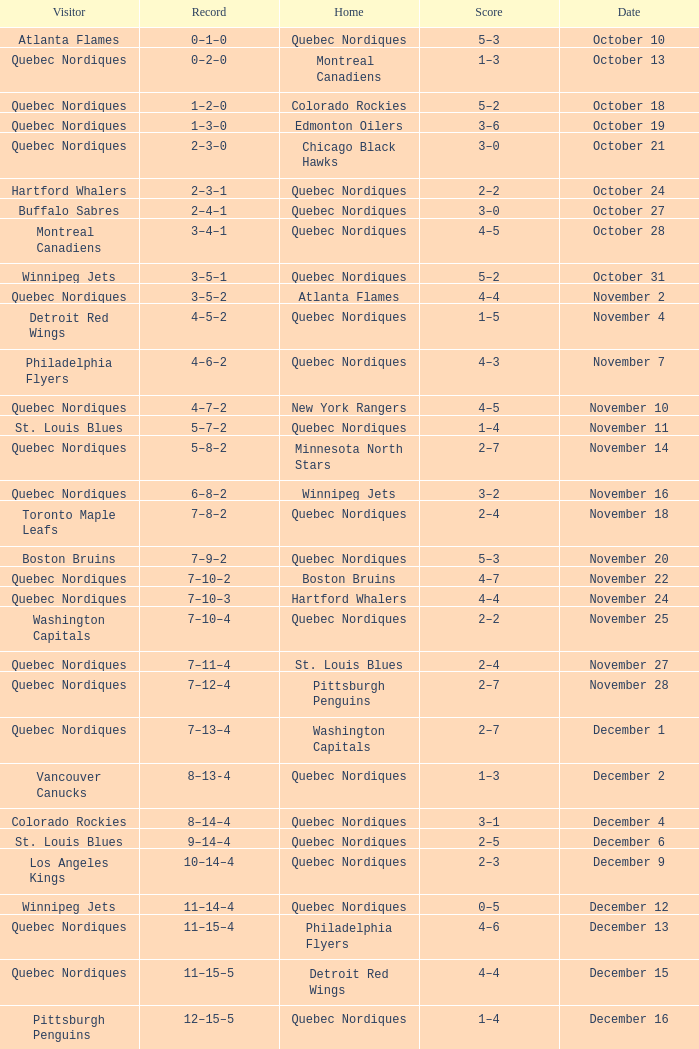Give me the full table as a dictionary. {'header': ['Visitor', 'Record', 'Home', 'Score', 'Date'], 'rows': [['Atlanta Flames', '0–1–0', 'Quebec Nordiques', '5–3', 'October 10'], ['Quebec Nordiques', '0–2–0', 'Montreal Canadiens', '1–3', 'October 13'], ['Quebec Nordiques', '1–2–0', 'Colorado Rockies', '5–2', 'October 18'], ['Quebec Nordiques', '1–3–0', 'Edmonton Oilers', '3–6', 'October 19'], ['Quebec Nordiques', '2–3–0', 'Chicago Black Hawks', '3–0', 'October 21'], ['Hartford Whalers', '2–3–1', 'Quebec Nordiques', '2–2', 'October 24'], ['Buffalo Sabres', '2–4–1', 'Quebec Nordiques', '3–0', 'October 27'], ['Montreal Canadiens', '3–4–1', 'Quebec Nordiques', '4–5', 'October 28'], ['Winnipeg Jets', '3–5–1', 'Quebec Nordiques', '5–2', 'October 31'], ['Quebec Nordiques', '3–5–2', 'Atlanta Flames', '4–4', 'November 2'], ['Detroit Red Wings', '4–5–2', 'Quebec Nordiques', '1–5', 'November 4'], ['Philadelphia Flyers', '4–6–2', 'Quebec Nordiques', '4–3', 'November 7'], ['Quebec Nordiques', '4–7–2', 'New York Rangers', '4–5', 'November 10'], ['St. Louis Blues', '5–7–2', 'Quebec Nordiques', '1–4', 'November 11'], ['Quebec Nordiques', '5–8–2', 'Minnesota North Stars', '2–7', 'November 14'], ['Quebec Nordiques', '6–8–2', 'Winnipeg Jets', '3–2', 'November 16'], ['Toronto Maple Leafs', '7–8–2', 'Quebec Nordiques', '2–4', 'November 18'], ['Boston Bruins', '7–9–2', 'Quebec Nordiques', '5–3', 'November 20'], ['Quebec Nordiques', '7–10–2', 'Boston Bruins', '4–7', 'November 22'], ['Quebec Nordiques', '7–10–3', 'Hartford Whalers', '4–4', 'November 24'], ['Washington Capitals', '7–10–4', 'Quebec Nordiques', '2–2', 'November 25'], ['Quebec Nordiques', '7–11–4', 'St. Louis Blues', '2–4', 'November 27'], ['Quebec Nordiques', '7–12–4', 'Pittsburgh Penguins', '2–7', 'November 28'], ['Quebec Nordiques', '7–13–4', 'Washington Capitals', '2–7', 'December 1'], ['Vancouver Canucks', '8–13-4', 'Quebec Nordiques', '1–3', 'December 2'], ['Colorado Rockies', '8–14–4', 'Quebec Nordiques', '3–1', 'December 4'], ['St. Louis Blues', '9–14–4', 'Quebec Nordiques', '2–5', 'December 6'], ['Los Angeles Kings', '10–14–4', 'Quebec Nordiques', '2–3', 'December 9'], ['Winnipeg Jets', '11–14–4', 'Quebec Nordiques', '0–5', 'December 12'], ['Quebec Nordiques', '11–15–4', 'Philadelphia Flyers', '4–6', 'December 13'], ['Quebec Nordiques', '11–15–5', 'Detroit Red Wings', '4–4', 'December 15'], ['Pittsburgh Penguins', '12–15–5', 'Quebec Nordiques', '1–4', 'December 16'], ['Colorado Rockies', '13–15–5', 'Quebec Nordiques', '3–6', 'December 19'], ['Quebec Nordiques', '14–15–5', 'Buffalo Sabres', '3–1', 'December 23'], ['Quebec Nordiques', '14–16–5', 'Los Angeles Kings', '0–3', 'December 27'], ['Quebec Nordiques', '14–17–5', 'Vancouver Canucks', '2–6', 'December 29'], ['Quebec Nordiques', '15–17–5', 'Edmonton Oilers', '2–1', 'December 30'], ['New York Rangers', '15–17–6', 'Quebec Nordiques', '3–3', 'January 2'], ['Quebec Nordiques', '16–17–6', 'Toronto Maple Leafs', '7–3', 'January 5'], ['Edmonton Oilers', '17–17–6', 'Quebec Nordiques', '2–3', 'January 9'], ['Quebec Nordiques', '17–18–6', 'Atlanta Flames', '3–4', 'January 11'], ['Quebec Nordiques', '17–19–6', 'St. Louis Blues', '2–8', 'January 12'], ['Boston Bruins', '17–20–6', 'Quebec Nordiques', '3–1', 'January 16'], ['Quebec Nordiques', '17–21–6', 'New York Islanders', '1–3', 'January 19'], ['Washington Capitals', '18–21–6', 'Quebec Nordiques', '2–3', 'January 20'], ['Minnesota North Stars', '19-21–6', 'Quebec Nordiques', '4–6', 'January 23'], ['Quebec Nordiques', '19–21–7', 'Washington Capitals', '1–1', 'January 26'], ['Detroit Red Wings', '19–22–7', 'Quebec Nordiques', '7–6', 'January 27'], ['Atlanta Flames', '19–23–7', 'Quebec Nordiques', '4–1', 'January 30'], ['Quebec Nordiques', '19–24–7', 'Boston Bruins', '2–7', 'February 2'], ['New York Rangers', '20–24–7', 'Quebec Nordiques', '4–5', 'February 3'], ['Chicago Black Hawks', '20–24–8', 'Quebec Nordiques', '3–3', 'February 6'], ['Quebec Nordiques', '20–25–8', 'New York Islanders', '0–5', 'February 9'], ['Quebec Nordiques', '20–26–8', 'New York Rangers', '1–3', 'February 10'], ['Quebec Nordiques', '20–27–8', 'Montreal Canadiens', '1–5', 'February 14'], ['Quebec Nordiques', '20–28–8', 'Winnipeg Jets', '5–6', 'February 17'], ['Quebec Nordiques', '20–29–8', 'Minnesota North Stars', '2–6', 'February 18'], ['Buffalo Sabres', '20–30–8', 'Quebec Nordiques', '3–1', 'February 19'], ['Quebec Nordiques', '20–31–8', 'Pittsburgh Penguins', '1–2', 'February 23'], ['Pittsburgh Penguins', '21–31–8', 'Quebec Nordiques', '0–2', 'February 24'], ['Hartford Whalers', '22–31–8', 'Quebec Nordiques', '5–9', 'February 26'], ['New York Islanders', '22–32–8', 'Quebec Nordiques', '5–3', 'February 27'], ['Los Angeles Kings', '22–33–8', 'Quebec Nordiques', '4–3', 'March 2'], ['Minnesota North Stars', '22–33–9', 'Quebec Nordiques', '3-3', 'March 5'], ['Quebec Nordiques', '22–34–9', 'Toronto Maple Leafs', '2–3', 'March 8'], ['Toronto Maple Leafs', '23–34-9', 'Quebec Nordiques', '4–5', 'March 9'], ['Edmonton Oilers', '23–35–9', 'Quebec Nordiques', '6–3', 'March 12'], ['Vancouver Canucks', '23–36–9', 'Quebec Nordiques', '3–2', 'March 16'], ['Quebec Nordiques', '23–37–9', 'Chicago Black Hawks', '2–5', 'March 19'], ['Quebec Nordiques', '24–37–9', 'Colorado Rockies', '6–2', 'March 20'], ['Quebec Nordiques', '24–38-9', 'Los Angeles Kings', '1-4', 'March 22'], ['Quebec Nordiques', '25–38–9', 'Vancouver Canucks', '6–2', 'March 23'], ['Chicago Black Hawks', '25–39–9', 'Quebec Nordiques', '7–2', 'March 26'], ['Quebec Nordiques', '25–40–9', 'Philadelphia Flyers', '2–5', 'March 27'], ['Quebec Nordiques', '25–41–9', 'Detroit Red Wings', '7–9', 'March 29'], ['New York Islanders', '25–42–9', 'Quebec Nordiques', '9–6', 'March 30'], ['Philadelphia Flyers', '25–42–10', 'Quebec Nordiques', '3–3', 'April 1'], ['Quebec Nordiques', '25–43–10', 'Buffalo Sabres', '3–8', 'April 3'], ['Quebec Nordiques', '25–44–10', 'Hartford Whalers', '2–9', 'April 4'], ['Montreal Canadiens', '25–44–11', 'Quebec Nordiques', '4–4', 'April 6']]} Which Date has a Score of 2–7, and a Record of 5–8–2? November 14. 